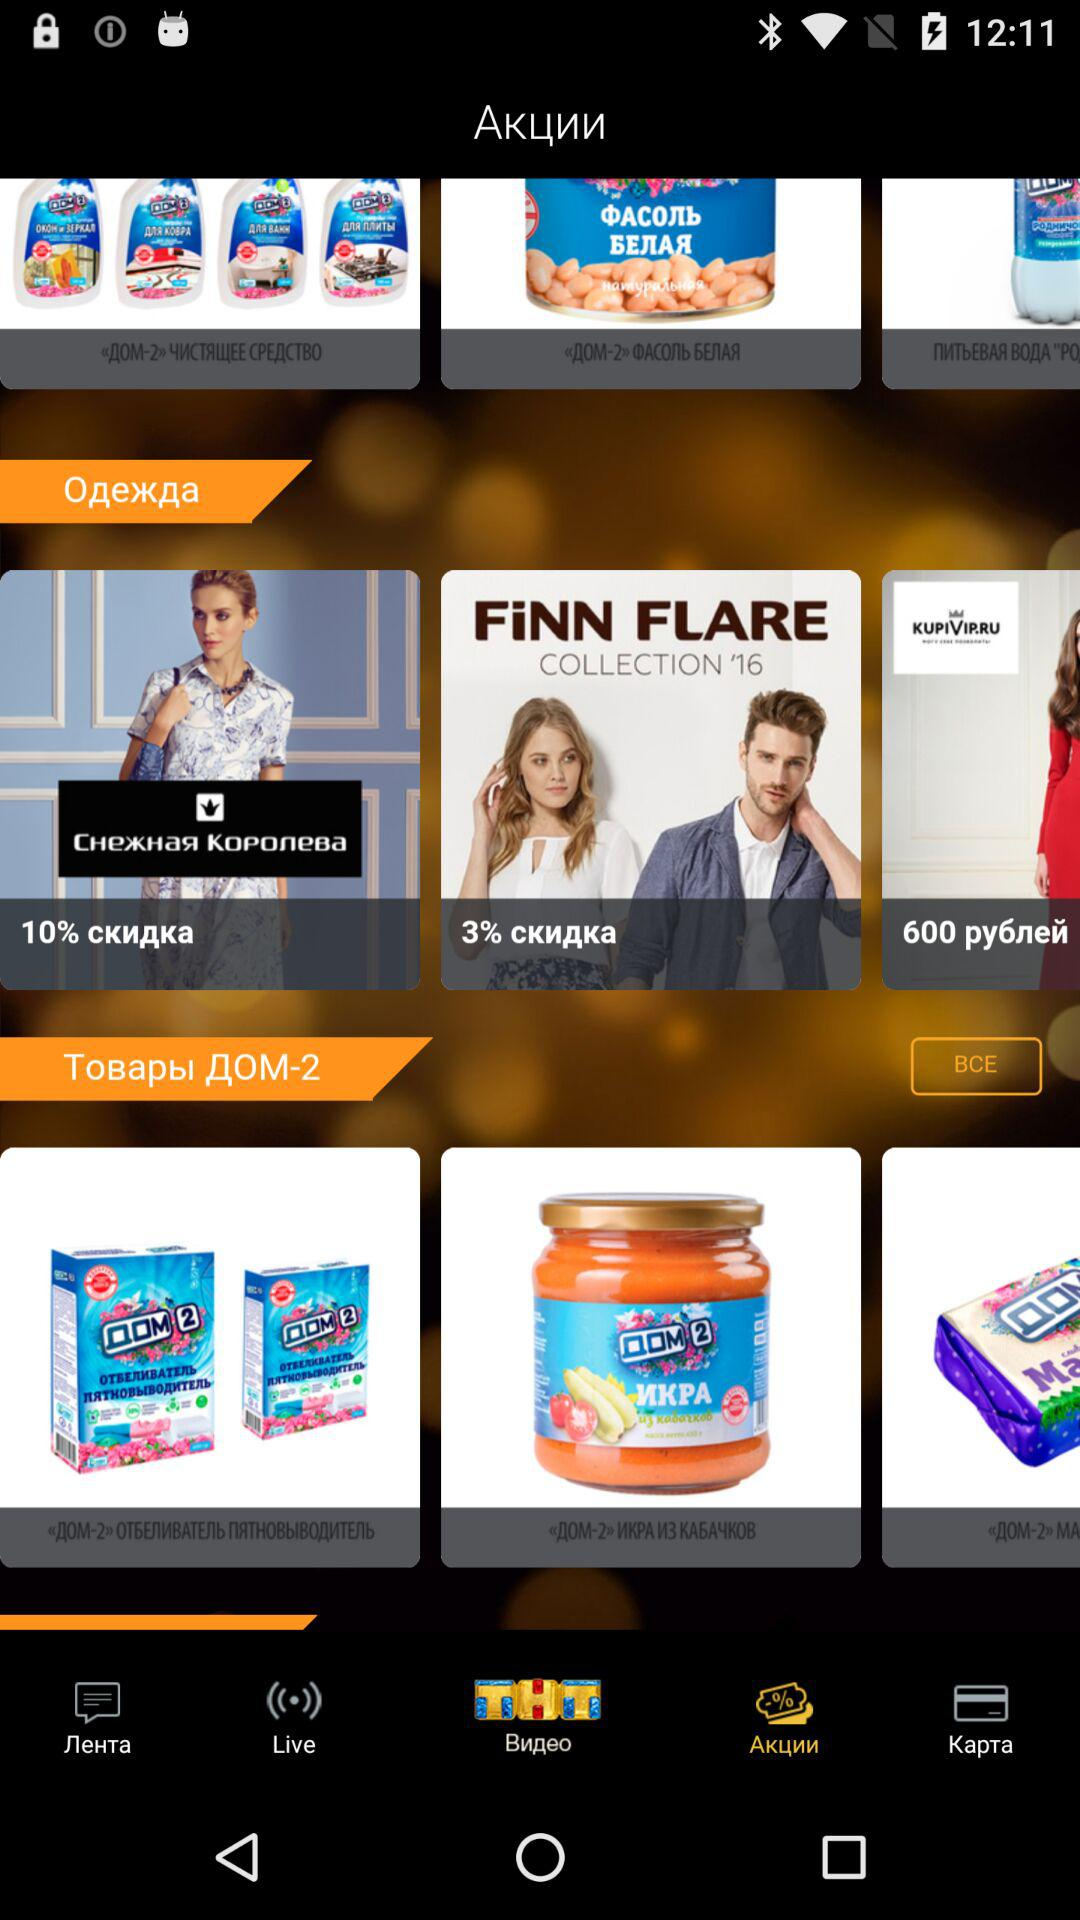How many products are in the Товары ДОМ-2 section?
Answer the question using a single word or phrase. 3 